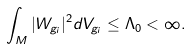<formula> <loc_0><loc_0><loc_500><loc_500>\int _ { M } | W _ { g _ { i } } | ^ { 2 } d V _ { g _ { i } } \leq \Lambda _ { 0 } < \infty .</formula> 